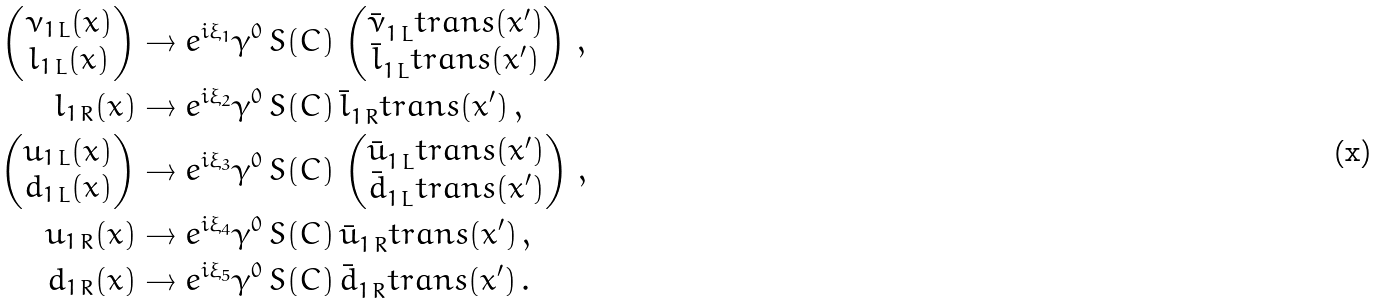<formula> <loc_0><loc_0><loc_500><loc_500>\begin{pmatrix} \nu _ { 1 \, L } ( x ) \\ l _ { 1 \, L } ( x ) \end{pmatrix} & \rightarrow e ^ { i \xi _ { 1 } } \gamma ^ { 0 } \, S ( C ) \, \begin{pmatrix} \bar { \nu } _ { 1 \, L } ^ { \ } t r a n s ( x ^ { \prime } ) \\ \bar { l } _ { 1 \, L } ^ { \ } t r a n s ( x ^ { \prime } ) \end{pmatrix} \, , \\ l _ { 1 \, R } ( x ) & \rightarrow e ^ { i \xi _ { 2 } } \gamma ^ { 0 } \, S ( C ) \, \bar { l } _ { 1 \, R } ^ { \ } t r a n s ( x ^ { \prime } ) \, , \\ \begin{pmatrix} u _ { 1 \, L } ( x ) \\ d _ { 1 \, L } ( x ) \end{pmatrix} & \rightarrow e ^ { i \xi _ { 3 } } \gamma ^ { 0 } \, S ( C ) \, \begin{pmatrix} \bar { u } _ { 1 \, L } ^ { \ } t r a n s ( x ^ { \prime } ) \\ \bar { d } _ { 1 \, L } ^ { \ } t r a n s ( x ^ { \prime } ) \end{pmatrix} \, , \\ u _ { 1 \, R } ( x ) & \rightarrow e ^ { i \xi _ { 4 } } \gamma ^ { 0 } \, S ( C ) \, \bar { u } _ { 1 \, R } ^ { \ } t r a n s ( x ^ { \prime } ) \, , \\ d _ { 1 \, R } ( x ) & \rightarrow e ^ { i \xi _ { 5 } } \gamma ^ { 0 } \, S ( C ) \, \bar { d } _ { 1 \, R } ^ { \ } t r a n s ( x ^ { \prime } ) \, .</formula> 